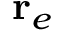<formula> <loc_0><loc_0><loc_500><loc_500>r _ { e }</formula> 